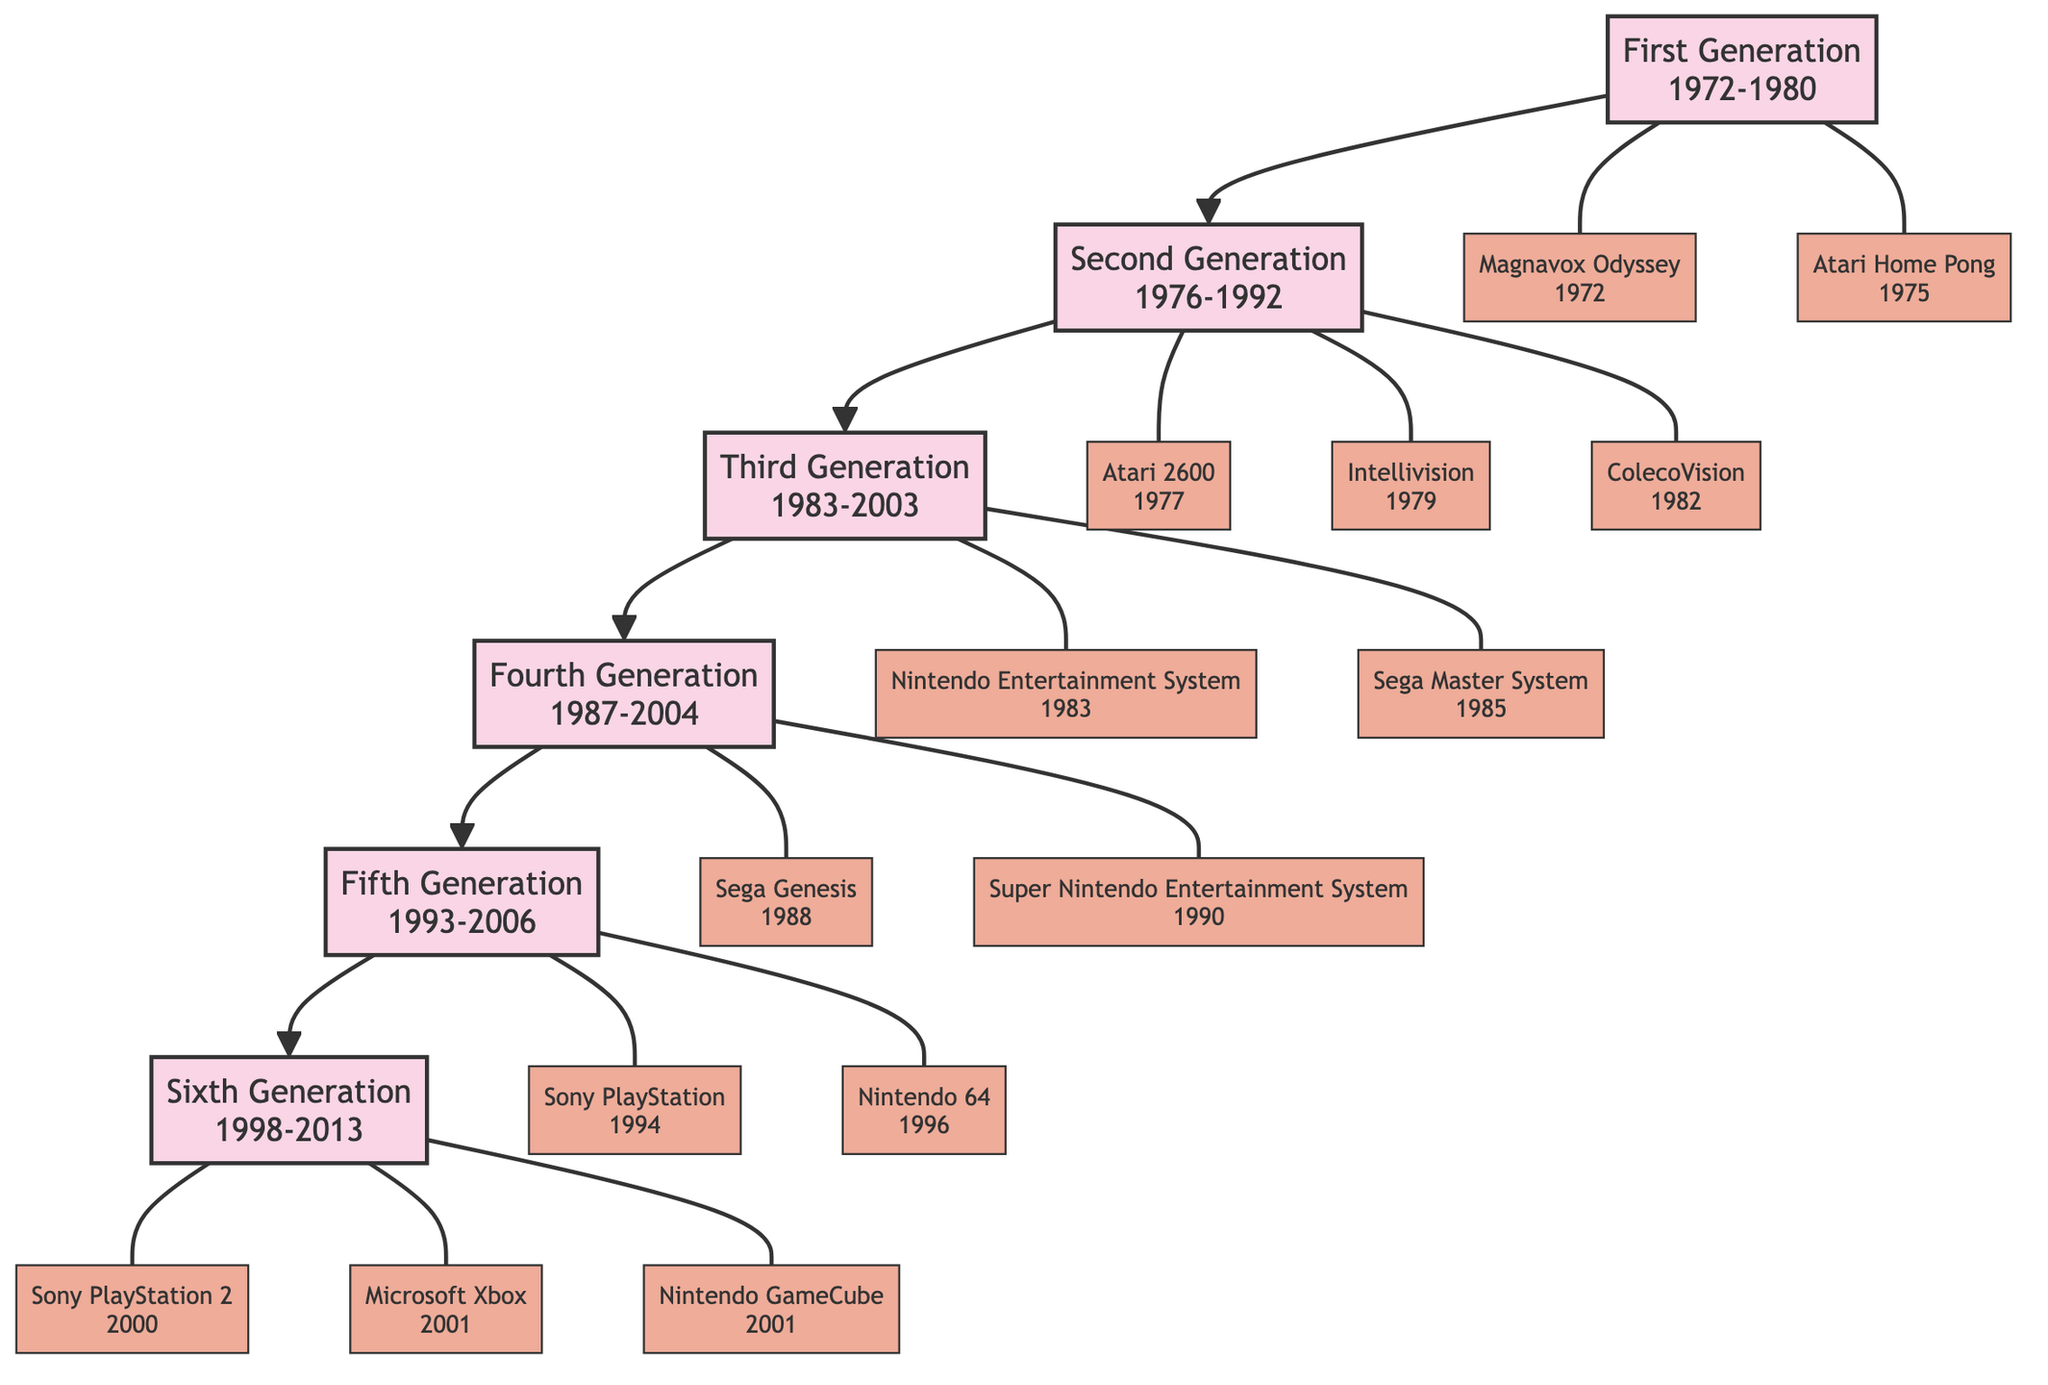What is the first generation of gaming consoles? The root node of the family tree indicates "First Generation" as the starting point of the diagram.
Answer: First Generation In what year range was the Second Generation released? The node for the Second Generation provides the year range "1976-1992."
Answer: 1976-1992 How many consoles are listed in the Third Generation? The Third Generation node contains two consoles: Nintendo Entertainment System (NES) and Sega Master System. Counting these gives a total of two consoles.
Answer: 2 Which console was released in 1988? The Fourth Generation node has a console listed as Sega Genesis, which specifies the release year of 1988.
Answer: Sega Genesis What is the relationship between "Atari 2600" and "Second Generation"? The "Atari 2600" is a console under the Second Generation node, indicating that it is part of that gaming generation in the family tree.
Answer: Part of Second Generation Which Generation do the PlayStation 2 and Nintendo GameCube belong to? Both of these consoles are listed under the Sixth Generation node, suggesting they are part of that generation of gaming consoles.
Answer: Sixth Generation What is the release year of the latest console shown in the diagram? The latest console listed is the Nintendo GameCube, which has a release year of 2001 according to the Sixth Generation details.
Answer: 2001 How many generations are represented in the family tree? The diagram shows a total of six generations, from First Generation to Sixth Generation, indicating a comprehensive history of gaming consoles.
Answer: 6 What is the earliest console mentioned in the diagram? The diagram specifies the Magnavox Odyssey as the earliest console under the First Generation released in 1972, which makes it the first console mentioned.
Answer: Magnavox Odyssey 